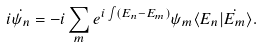<formula> <loc_0><loc_0><loc_500><loc_500>i \dot { \psi _ { n } } = - i \sum _ { m } e ^ { i \int ( E _ { n } - E _ { m } ) } \psi _ { m } \langle E _ { n } | \dot { E _ { m } } \rangle .</formula> 